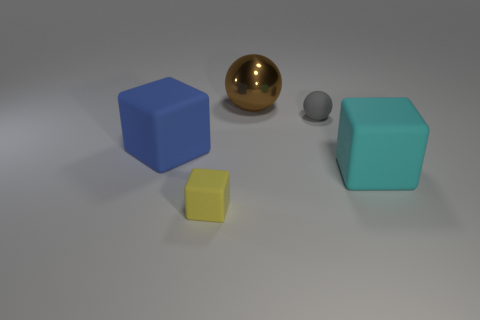Add 4 tiny gray rubber balls. How many objects exist? 9 Subtract all cubes. How many objects are left? 2 Add 5 brown shiny spheres. How many brown shiny spheres exist? 6 Subtract 1 blue cubes. How many objects are left? 4 Subtract all matte cubes. Subtract all big brown shiny things. How many objects are left? 1 Add 1 matte things. How many matte things are left? 5 